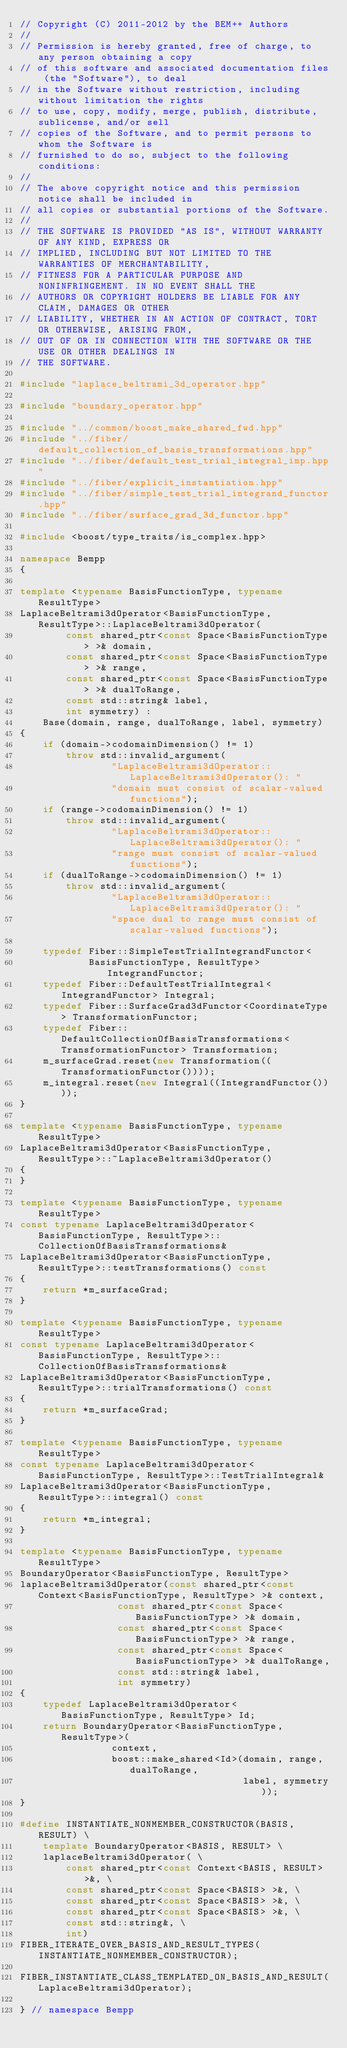<code> <loc_0><loc_0><loc_500><loc_500><_C++_>// Copyright (C) 2011-2012 by the BEM++ Authors
//
// Permission is hereby granted, free of charge, to any person obtaining a copy
// of this software and associated documentation files (the "Software"), to deal
// in the Software without restriction, including without limitation the rights
// to use, copy, modify, merge, publish, distribute, sublicense, and/or sell
// copies of the Software, and to permit persons to whom the Software is
// furnished to do so, subject to the following conditions:
//
// The above copyright notice and this permission notice shall be included in
// all copies or substantial portions of the Software.
//
// THE SOFTWARE IS PROVIDED "AS IS", WITHOUT WARRANTY OF ANY KIND, EXPRESS OR
// IMPLIED, INCLUDING BUT NOT LIMITED TO THE WARRANTIES OF MERCHANTABILITY,
// FITNESS FOR A PARTICULAR PURPOSE AND NONINFRINGEMENT. IN NO EVENT SHALL THE
// AUTHORS OR COPYRIGHT HOLDERS BE LIABLE FOR ANY CLAIM, DAMAGES OR OTHER
// LIABILITY, WHETHER IN AN ACTION OF CONTRACT, TORT OR OTHERWISE, ARISING FROM,
// OUT OF OR IN CONNECTION WITH THE SOFTWARE OR THE USE OR OTHER DEALINGS IN
// THE SOFTWARE.

#include "laplace_beltrami_3d_operator.hpp"

#include "boundary_operator.hpp"

#include "../common/boost_make_shared_fwd.hpp"
#include "../fiber/default_collection_of_basis_transformations.hpp"
#include "../fiber/default_test_trial_integral_imp.hpp"
#include "../fiber/explicit_instantiation.hpp"
#include "../fiber/simple_test_trial_integrand_functor.hpp"
#include "../fiber/surface_grad_3d_functor.hpp"

#include <boost/type_traits/is_complex.hpp>

namespace Bempp
{

template <typename BasisFunctionType, typename ResultType>
LaplaceBeltrami3dOperator<BasisFunctionType, ResultType>::LaplaceBeltrami3dOperator(
        const shared_ptr<const Space<BasisFunctionType> >& domain,
        const shared_ptr<const Space<BasisFunctionType> >& range,
        const shared_ptr<const Space<BasisFunctionType> >& dualToRange,
        const std::string& label,
        int symmetry) :
    Base(domain, range, dualToRange, label, symmetry)
{
    if (domain->codomainDimension() != 1)
        throw std::invalid_argument(
                "LaplaceBeltrami3dOperator::LaplaceBeltrami3dOperator(): "
                "domain must consist of scalar-valued functions");
    if (range->codomainDimension() != 1)
        throw std::invalid_argument(
                "LaplaceBeltrami3dOperator::LaplaceBeltrami3dOperator(): "
                "range must consist of scalar-valued functions");
    if (dualToRange->codomainDimension() != 1)
        throw std::invalid_argument(
                "LaplaceBeltrami3dOperator::LaplaceBeltrami3dOperator(): "
                "space dual to range must consist of scalar-valued functions");

    typedef Fiber::SimpleTestTrialIntegrandFunctor<
            BasisFunctionType, ResultType> IntegrandFunctor;
    typedef Fiber::DefaultTestTrialIntegral<IntegrandFunctor> Integral;
    typedef Fiber::SurfaceGrad3dFunctor<CoordinateType> TransformationFunctor;
    typedef Fiber::DefaultCollectionOfBasisTransformations<TransformationFunctor> Transformation;
    m_surfaceGrad.reset(new Transformation((TransformationFunctor())));
    m_integral.reset(new Integral((IntegrandFunctor())));
}

template <typename BasisFunctionType, typename ResultType>
LaplaceBeltrami3dOperator<BasisFunctionType, ResultType>::~LaplaceBeltrami3dOperator()
{
}

template <typename BasisFunctionType, typename ResultType>
const typename LaplaceBeltrami3dOperator<BasisFunctionType, ResultType>::CollectionOfBasisTransformations&
LaplaceBeltrami3dOperator<BasisFunctionType, ResultType>::testTransformations() const
{
    return *m_surfaceGrad;
}

template <typename BasisFunctionType, typename ResultType>
const typename LaplaceBeltrami3dOperator<BasisFunctionType, ResultType>::CollectionOfBasisTransformations&
LaplaceBeltrami3dOperator<BasisFunctionType, ResultType>::trialTransformations() const
{
    return *m_surfaceGrad;
}

template <typename BasisFunctionType, typename ResultType>
const typename LaplaceBeltrami3dOperator<BasisFunctionType, ResultType>::TestTrialIntegral&
LaplaceBeltrami3dOperator<BasisFunctionType, ResultType>::integral() const
{
    return *m_integral;
}

template <typename BasisFunctionType, typename ResultType>
BoundaryOperator<BasisFunctionType, ResultType>
laplaceBeltrami3dOperator(const shared_ptr<const Context<BasisFunctionType, ResultType> >& context,
                 const shared_ptr<const Space<BasisFunctionType> >& domain,
                 const shared_ptr<const Space<BasisFunctionType> >& range,
                 const shared_ptr<const Space<BasisFunctionType> >& dualToRange,
                 const std::string& label,
                 int symmetry)
{
    typedef LaplaceBeltrami3dOperator<BasisFunctionType, ResultType> Id;
    return BoundaryOperator<BasisFunctionType, ResultType>(
                context,
                boost::make_shared<Id>(domain, range, dualToRange,
                                       label, symmetry));
}

#define INSTANTIATE_NONMEMBER_CONSTRUCTOR(BASIS, RESULT) \
    template BoundaryOperator<BASIS, RESULT> \
    laplaceBeltrami3dOperator( \
        const shared_ptr<const Context<BASIS, RESULT> >&, \
        const shared_ptr<const Space<BASIS> >&, \
        const shared_ptr<const Space<BASIS> >&, \
        const shared_ptr<const Space<BASIS> >&, \
        const std::string&, \
        int)
FIBER_ITERATE_OVER_BASIS_AND_RESULT_TYPES(INSTANTIATE_NONMEMBER_CONSTRUCTOR);

FIBER_INSTANTIATE_CLASS_TEMPLATED_ON_BASIS_AND_RESULT(LaplaceBeltrami3dOperator);

} // namespace Bempp
</code> 